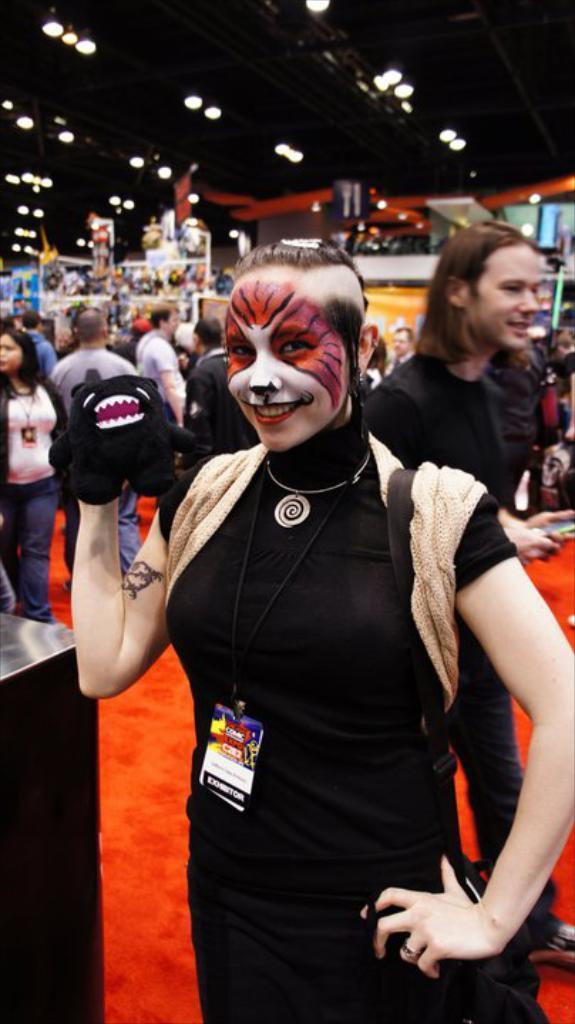Describe this image in one or two sentences. This image is taken indoors. At the bottom of the image there is a red carpet. In the middle of the image a woman is standing on the floor and holding a mask in her hand. In the background a few people are standing on the floor and there are a few things. At the top of the image there is a roof with lights. On the left side of the image there is a table. 